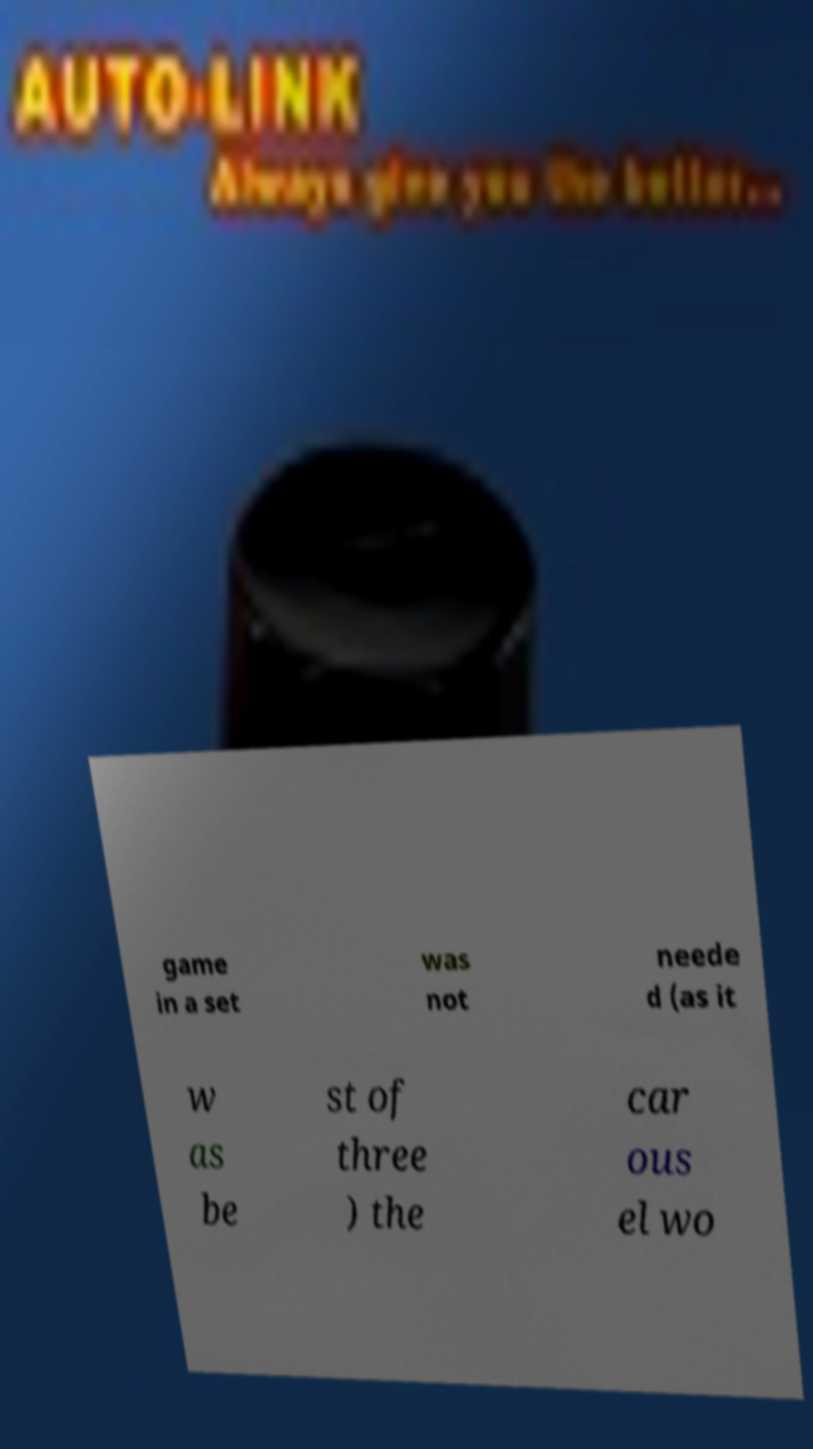I need the written content from this picture converted into text. Can you do that? game in a set was not neede d (as it w as be st of three ) the car ous el wo 